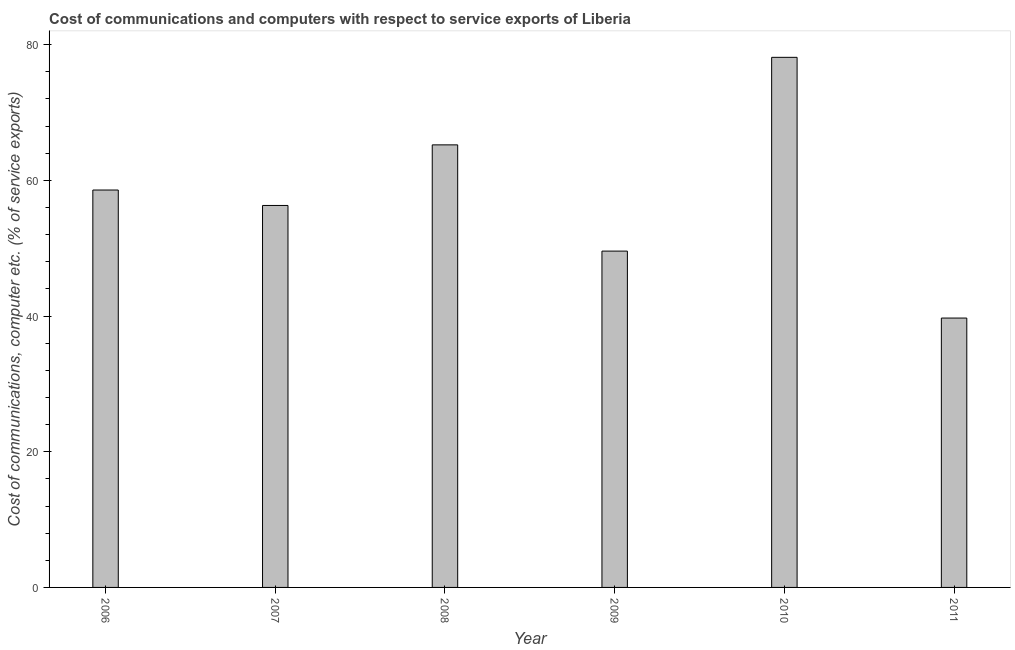Does the graph contain any zero values?
Your response must be concise. No. What is the title of the graph?
Keep it short and to the point. Cost of communications and computers with respect to service exports of Liberia. What is the label or title of the X-axis?
Make the answer very short. Year. What is the label or title of the Y-axis?
Offer a terse response. Cost of communications, computer etc. (% of service exports). What is the cost of communications and computer in 2007?
Your answer should be very brief. 56.29. Across all years, what is the maximum cost of communications and computer?
Your answer should be very brief. 78.13. Across all years, what is the minimum cost of communications and computer?
Provide a succinct answer. 39.7. What is the sum of the cost of communications and computer?
Offer a very short reply. 347.48. What is the difference between the cost of communications and computer in 2006 and 2007?
Offer a terse response. 2.28. What is the average cost of communications and computer per year?
Provide a succinct answer. 57.91. What is the median cost of communications and computer?
Keep it short and to the point. 57.43. In how many years, is the cost of communications and computer greater than 44 %?
Provide a succinct answer. 5. Do a majority of the years between 2010 and 2007 (inclusive) have cost of communications and computer greater than 8 %?
Ensure brevity in your answer.  Yes. What is the ratio of the cost of communications and computer in 2006 to that in 2011?
Provide a short and direct response. 1.48. Is the cost of communications and computer in 2010 less than that in 2011?
Give a very brief answer. No. Is the difference between the cost of communications and computer in 2007 and 2010 greater than the difference between any two years?
Your answer should be very brief. No. What is the difference between the highest and the second highest cost of communications and computer?
Your answer should be very brief. 12.9. What is the difference between the highest and the lowest cost of communications and computer?
Offer a very short reply. 38.43. How many years are there in the graph?
Provide a short and direct response. 6. What is the difference between two consecutive major ticks on the Y-axis?
Provide a short and direct response. 20. What is the Cost of communications, computer etc. (% of service exports) of 2006?
Your answer should be compact. 58.57. What is the Cost of communications, computer etc. (% of service exports) in 2007?
Give a very brief answer. 56.29. What is the Cost of communications, computer etc. (% of service exports) in 2008?
Ensure brevity in your answer.  65.23. What is the Cost of communications, computer etc. (% of service exports) of 2009?
Offer a terse response. 49.57. What is the Cost of communications, computer etc. (% of service exports) of 2010?
Your answer should be very brief. 78.13. What is the Cost of communications, computer etc. (% of service exports) in 2011?
Your response must be concise. 39.7. What is the difference between the Cost of communications, computer etc. (% of service exports) in 2006 and 2007?
Your answer should be compact. 2.28. What is the difference between the Cost of communications, computer etc. (% of service exports) in 2006 and 2008?
Ensure brevity in your answer.  -6.66. What is the difference between the Cost of communications, computer etc. (% of service exports) in 2006 and 2009?
Provide a succinct answer. 9. What is the difference between the Cost of communications, computer etc. (% of service exports) in 2006 and 2010?
Keep it short and to the point. -19.56. What is the difference between the Cost of communications, computer etc. (% of service exports) in 2006 and 2011?
Ensure brevity in your answer.  18.87. What is the difference between the Cost of communications, computer etc. (% of service exports) in 2007 and 2008?
Your answer should be very brief. -8.93. What is the difference between the Cost of communications, computer etc. (% of service exports) in 2007 and 2009?
Give a very brief answer. 6.73. What is the difference between the Cost of communications, computer etc. (% of service exports) in 2007 and 2010?
Your response must be concise. -21.83. What is the difference between the Cost of communications, computer etc. (% of service exports) in 2007 and 2011?
Your response must be concise. 16.59. What is the difference between the Cost of communications, computer etc. (% of service exports) in 2008 and 2009?
Your response must be concise. 15.66. What is the difference between the Cost of communications, computer etc. (% of service exports) in 2008 and 2010?
Offer a terse response. -12.9. What is the difference between the Cost of communications, computer etc. (% of service exports) in 2008 and 2011?
Offer a terse response. 25.53. What is the difference between the Cost of communications, computer etc. (% of service exports) in 2009 and 2010?
Your response must be concise. -28.56. What is the difference between the Cost of communications, computer etc. (% of service exports) in 2009 and 2011?
Keep it short and to the point. 9.87. What is the difference between the Cost of communications, computer etc. (% of service exports) in 2010 and 2011?
Make the answer very short. 38.43. What is the ratio of the Cost of communications, computer etc. (% of service exports) in 2006 to that in 2008?
Give a very brief answer. 0.9. What is the ratio of the Cost of communications, computer etc. (% of service exports) in 2006 to that in 2009?
Offer a very short reply. 1.18. What is the ratio of the Cost of communications, computer etc. (% of service exports) in 2006 to that in 2010?
Provide a succinct answer. 0.75. What is the ratio of the Cost of communications, computer etc. (% of service exports) in 2006 to that in 2011?
Provide a short and direct response. 1.48. What is the ratio of the Cost of communications, computer etc. (% of service exports) in 2007 to that in 2008?
Provide a short and direct response. 0.86. What is the ratio of the Cost of communications, computer etc. (% of service exports) in 2007 to that in 2009?
Offer a terse response. 1.14. What is the ratio of the Cost of communications, computer etc. (% of service exports) in 2007 to that in 2010?
Offer a terse response. 0.72. What is the ratio of the Cost of communications, computer etc. (% of service exports) in 2007 to that in 2011?
Offer a terse response. 1.42. What is the ratio of the Cost of communications, computer etc. (% of service exports) in 2008 to that in 2009?
Offer a very short reply. 1.32. What is the ratio of the Cost of communications, computer etc. (% of service exports) in 2008 to that in 2010?
Ensure brevity in your answer.  0.83. What is the ratio of the Cost of communications, computer etc. (% of service exports) in 2008 to that in 2011?
Make the answer very short. 1.64. What is the ratio of the Cost of communications, computer etc. (% of service exports) in 2009 to that in 2010?
Provide a short and direct response. 0.63. What is the ratio of the Cost of communications, computer etc. (% of service exports) in 2009 to that in 2011?
Offer a very short reply. 1.25. What is the ratio of the Cost of communications, computer etc. (% of service exports) in 2010 to that in 2011?
Provide a short and direct response. 1.97. 